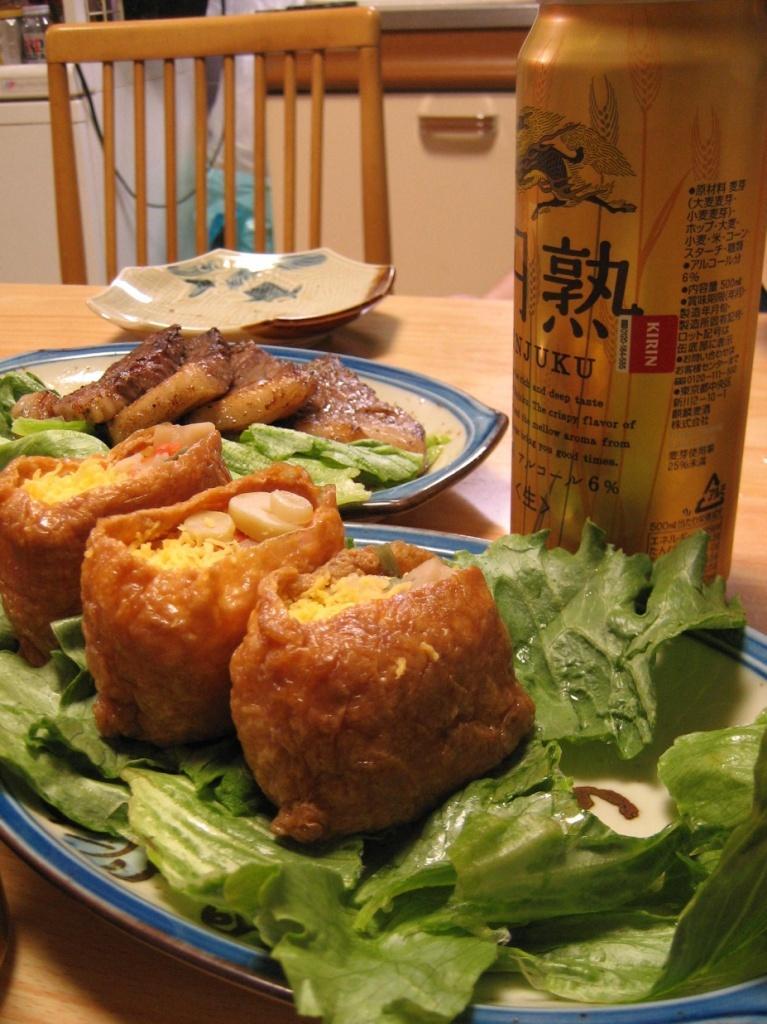How would you summarize this image in a sentence or two? In this image, we can see a table with some food items in plates. We can also see a plate and a bottle. We can also see a chair. In the background, we can see some objects. 